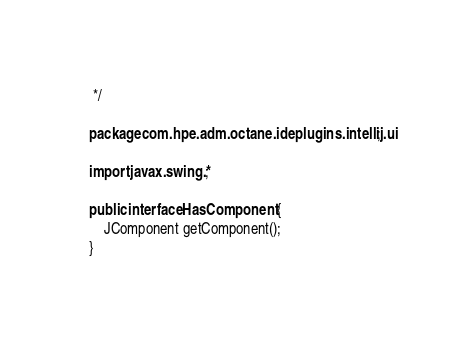Convert code to text. <code><loc_0><loc_0><loc_500><loc_500><_Java_> */

package com.hpe.adm.octane.ideplugins.intellij.ui;

import javax.swing.*;

public interface HasComponent {
    JComponent getComponent();
}
</code> 